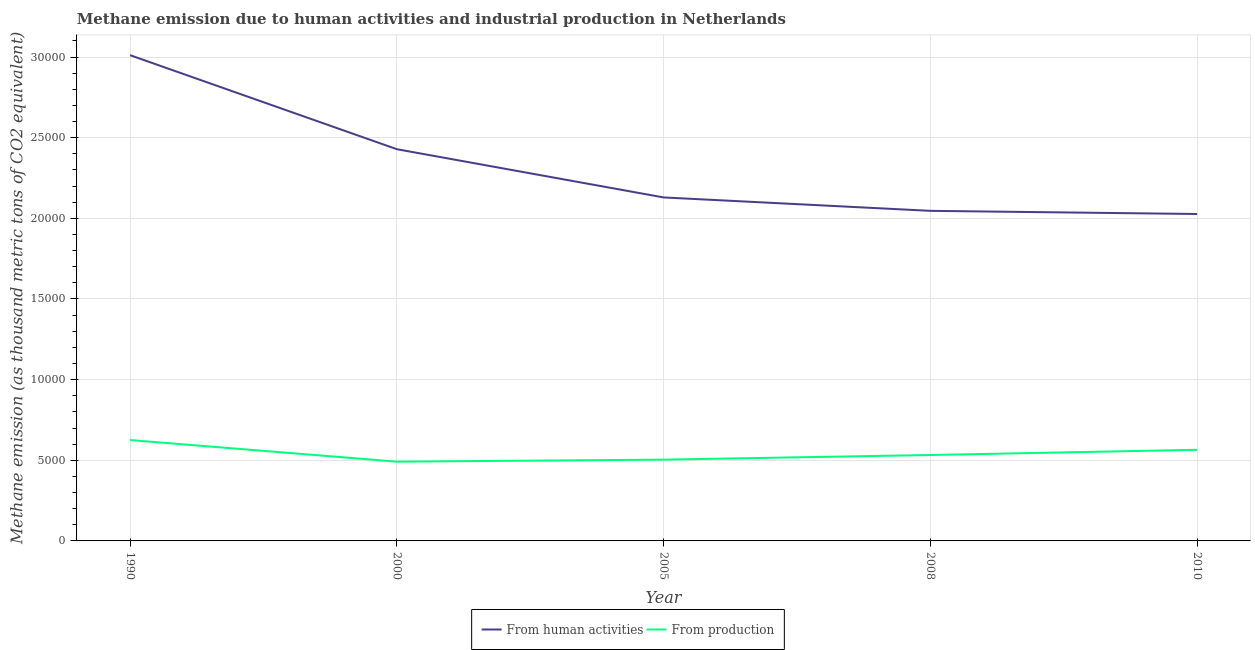How many different coloured lines are there?
Offer a very short reply. 2. Does the line corresponding to amount of emissions generated from industries intersect with the line corresponding to amount of emissions from human activities?
Give a very brief answer. No. What is the amount of emissions generated from industries in 2008?
Keep it short and to the point. 5326.8. Across all years, what is the maximum amount of emissions from human activities?
Make the answer very short. 3.01e+04. Across all years, what is the minimum amount of emissions from human activities?
Give a very brief answer. 2.03e+04. In which year was the amount of emissions from human activities maximum?
Your response must be concise. 1990. In which year was the amount of emissions from human activities minimum?
Offer a terse response. 2010. What is the total amount of emissions generated from industries in the graph?
Your response must be concise. 2.72e+04. What is the difference between the amount of emissions generated from industries in 2008 and that in 2010?
Make the answer very short. -323.2. What is the difference between the amount of emissions from human activities in 2010 and the amount of emissions generated from industries in 1990?
Provide a short and direct response. 1.40e+04. What is the average amount of emissions from human activities per year?
Offer a very short reply. 2.33e+04. In the year 1990, what is the difference between the amount of emissions generated from industries and amount of emissions from human activities?
Provide a short and direct response. -2.39e+04. In how many years, is the amount of emissions generated from industries greater than 7000 thousand metric tons?
Offer a very short reply. 0. What is the ratio of the amount of emissions from human activities in 1990 to that in 2005?
Ensure brevity in your answer.  1.41. Is the amount of emissions from human activities in 2005 less than that in 2008?
Your answer should be compact. No. What is the difference between the highest and the second highest amount of emissions from human activities?
Make the answer very short. 5828.3. What is the difference between the highest and the lowest amount of emissions from human activities?
Your answer should be compact. 9845.8. Is the sum of the amount of emissions generated from industries in 1990 and 2000 greater than the maximum amount of emissions from human activities across all years?
Give a very brief answer. No. Is the amount of emissions generated from industries strictly greater than the amount of emissions from human activities over the years?
Ensure brevity in your answer.  No. Is the amount of emissions generated from industries strictly less than the amount of emissions from human activities over the years?
Your response must be concise. Yes. How many lines are there?
Keep it short and to the point. 2. How many years are there in the graph?
Your response must be concise. 5. Are the values on the major ticks of Y-axis written in scientific E-notation?
Keep it short and to the point. No. Does the graph contain any zero values?
Make the answer very short. No. Does the graph contain grids?
Make the answer very short. Yes. Where does the legend appear in the graph?
Offer a very short reply. Bottom center. How many legend labels are there?
Keep it short and to the point. 2. How are the legend labels stacked?
Your answer should be compact. Horizontal. What is the title of the graph?
Ensure brevity in your answer.  Methane emission due to human activities and industrial production in Netherlands. What is the label or title of the Y-axis?
Your answer should be very brief. Methane emission (as thousand metric tons of CO2 equivalent). What is the Methane emission (as thousand metric tons of CO2 equivalent) of From human activities in 1990?
Your answer should be very brief. 3.01e+04. What is the Methane emission (as thousand metric tons of CO2 equivalent) of From production in 1990?
Offer a very short reply. 6254.4. What is the Methane emission (as thousand metric tons of CO2 equivalent) of From human activities in 2000?
Provide a succinct answer. 2.43e+04. What is the Methane emission (as thousand metric tons of CO2 equivalent) in From production in 2000?
Ensure brevity in your answer.  4913.4. What is the Methane emission (as thousand metric tons of CO2 equivalent) in From human activities in 2005?
Your answer should be compact. 2.13e+04. What is the Methane emission (as thousand metric tons of CO2 equivalent) of From production in 2005?
Offer a terse response. 5039.5. What is the Methane emission (as thousand metric tons of CO2 equivalent) of From human activities in 2008?
Make the answer very short. 2.05e+04. What is the Methane emission (as thousand metric tons of CO2 equivalent) in From production in 2008?
Provide a succinct answer. 5326.8. What is the Methane emission (as thousand metric tons of CO2 equivalent) of From human activities in 2010?
Your answer should be compact. 2.03e+04. What is the Methane emission (as thousand metric tons of CO2 equivalent) of From production in 2010?
Your answer should be very brief. 5650. Across all years, what is the maximum Methane emission (as thousand metric tons of CO2 equivalent) in From human activities?
Provide a short and direct response. 3.01e+04. Across all years, what is the maximum Methane emission (as thousand metric tons of CO2 equivalent) of From production?
Keep it short and to the point. 6254.4. Across all years, what is the minimum Methane emission (as thousand metric tons of CO2 equivalent) of From human activities?
Offer a very short reply. 2.03e+04. Across all years, what is the minimum Methane emission (as thousand metric tons of CO2 equivalent) in From production?
Give a very brief answer. 4913.4. What is the total Methane emission (as thousand metric tons of CO2 equivalent) of From human activities in the graph?
Ensure brevity in your answer.  1.16e+05. What is the total Methane emission (as thousand metric tons of CO2 equivalent) in From production in the graph?
Keep it short and to the point. 2.72e+04. What is the difference between the Methane emission (as thousand metric tons of CO2 equivalent) of From human activities in 1990 and that in 2000?
Provide a succinct answer. 5828.3. What is the difference between the Methane emission (as thousand metric tons of CO2 equivalent) of From production in 1990 and that in 2000?
Give a very brief answer. 1341. What is the difference between the Methane emission (as thousand metric tons of CO2 equivalent) in From human activities in 1990 and that in 2005?
Your answer should be very brief. 8818.6. What is the difference between the Methane emission (as thousand metric tons of CO2 equivalent) of From production in 1990 and that in 2005?
Make the answer very short. 1214.9. What is the difference between the Methane emission (as thousand metric tons of CO2 equivalent) in From human activities in 1990 and that in 2008?
Make the answer very short. 9650.1. What is the difference between the Methane emission (as thousand metric tons of CO2 equivalent) in From production in 1990 and that in 2008?
Offer a very short reply. 927.6. What is the difference between the Methane emission (as thousand metric tons of CO2 equivalent) in From human activities in 1990 and that in 2010?
Provide a succinct answer. 9845.8. What is the difference between the Methane emission (as thousand metric tons of CO2 equivalent) of From production in 1990 and that in 2010?
Give a very brief answer. 604.4. What is the difference between the Methane emission (as thousand metric tons of CO2 equivalent) of From human activities in 2000 and that in 2005?
Give a very brief answer. 2990.3. What is the difference between the Methane emission (as thousand metric tons of CO2 equivalent) in From production in 2000 and that in 2005?
Offer a very short reply. -126.1. What is the difference between the Methane emission (as thousand metric tons of CO2 equivalent) of From human activities in 2000 and that in 2008?
Make the answer very short. 3821.8. What is the difference between the Methane emission (as thousand metric tons of CO2 equivalent) in From production in 2000 and that in 2008?
Your answer should be compact. -413.4. What is the difference between the Methane emission (as thousand metric tons of CO2 equivalent) of From human activities in 2000 and that in 2010?
Make the answer very short. 4017.5. What is the difference between the Methane emission (as thousand metric tons of CO2 equivalent) of From production in 2000 and that in 2010?
Your response must be concise. -736.6. What is the difference between the Methane emission (as thousand metric tons of CO2 equivalent) in From human activities in 2005 and that in 2008?
Keep it short and to the point. 831.5. What is the difference between the Methane emission (as thousand metric tons of CO2 equivalent) in From production in 2005 and that in 2008?
Keep it short and to the point. -287.3. What is the difference between the Methane emission (as thousand metric tons of CO2 equivalent) in From human activities in 2005 and that in 2010?
Your answer should be very brief. 1027.2. What is the difference between the Methane emission (as thousand metric tons of CO2 equivalent) of From production in 2005 and that in 2010?
Offer a terse response. -610.5. What is the difference between the Methane emission (as thousand metric tons of CO2 equivalent) of From human activities in 2008 and that in 2010?
Provide a short and direct response. 195.7. What is the difference between the Methane emission (as thousand metric tons of CO2 equivalent) of From production in 2008 and that in 2010?
Offer a terse response. -323.2. What is the difference between the Methane emission (as thousand metric tons of CO2 equivalent) in From human activities in 1990 and the Methane emission (as thousand metric tons of CO2 equivalent) in From production in 2000?
Your answer should be compact. 2.52e+04. What is the difference between the Methane emission (as thousand metric tons of CO2 equivalent) in From human activities in 1990 and the Methane emission (as thousand metric tons of CO2 equivalent) in From production in 2005?
Your response must be concise. 2.51e+04. What is the difference between the Methane emission (as thousand metric tons of CO2 equivalent) in From human activities in 1990 and the Methane emission (as thousand metric tons of CO2 equivalent) in From production in 2008?
Provide a succinct answer. 2.48e+04. What is the difference between the Methane emission (as thousand metric tons of CO2 equivalent) of From human activities in 1990 and the Methane emission (as thousand metric tons of CO2 equivalent) of From production in 2010?
Ensure brevity in your answer.  2.45e+04. What is the difference between the Methane emission (as thousand metric tons of CO2 equivalent) of From human activities in 2000 and the Methane emission (as thousand metric tons of CO2 equivalent) of From production in 2005?
Give a very brief answer. 1.92e+04. What is the difference between the Methane emission (as thousand metric tons of CO2 equivalent) of From human activities in 2000 and the Methane emission (as thousand metric tons of CO2 equivalent) of From production in 2008?
Ensure brevity in your answer.  1.90e+04. What is the difference between the Methane emission (as thousand metric tons of CO2 equivalent) of From human activities in 2000 and the Methane emission (as thousand metric tons of CO2 equivalent) of From production in 2010?
Make the answer very short. 1.86e+04. What is the difference between the Methane emission (as thousand metric tons of CO2 equivalent) of From human activities in 2005 and the Methane emission (as thousand metric tons of CO2 equivalent) of From production in 2008?
Your answer should be very brief. 1.60e+04. What is the difference between the Methane emission (as thousand metric tons of CO2 equivalent) of From human activities in 2005 and the Methane emission (as thousand metric tons of CO2 equivalent) of From production in 2010?
Offer a terse response. 1.56e+04. What is the difference between the Methane emission (as thousand metric tons of CO2 equivalent) of From human activities in 2008 and the Methane emission (as thousand metric tons of CO2 equivalent) of From production in 2010?
Provide a succinct answer. 1.48e+04. What is the average Methane emission (as thousand metric tons of CO2 equivalent) in From human activities per year?
Offer a very short reply. 2.33e+04. What is the average Methane emission (as thousand metric tons of CO2 equivalent) in From production per year?
Your answer should be very brief. 5436.82. In the year 1990, what is the difference between the Methane emission (as thousand metric tons of CO2 equivalent) of From human activities and Methane emission (as thousand metric tons of CO2 equivalent) of From production?
Ensure brevity in your answer.  2.39e+04. In the year 2000, what is the difference between the Methane emission (as thousand metric tons of CO2 equivalent) of From human activities and Methane emission (as thousand metric tons of CO2 equivalent) of From production?
Make the answer very short. 1.94e+04. In the year 2005, what is the difference between the Methane emission (as thousand metric tons of CO2 equivalent) in From human activities and Methane emission (as thousand metric tons of CO2 equivalent) in From production?
Your response must be concise. 1.63e+04. In the year 2008, what is the difference between the Methane emission (as thousand metric tons of CO2 equivalent) of From human activities and Methane emission (as thousand metric tons of CO2 equivalent) of From production?
Give a very brief answer. 1.51e+04. In the year 2010, what is the difference between the Methane emission (as thousand metric tons of CO2 equivalent) in From human activities and Methane emission (as thousand metric tons of CO2 equivalent) in From production?
Give a very brief answer. 1.46e+04. What is the ratio of the Methane emission (as thousand metric tons of CO2 equivalent) of From human activities in 1990 to that in 2000?
Ensure brevity in your answer.  1.24. What is the ratio of the Methane emission (as thousand metric tons of CO2 equivalent) in From production in 1990 to that in 2000?
Provide a short and direct response. 1.27. What is the ratio of the Methane emission (as thousand metric tons of CO2 equivalent) in From human activities in 1990 to that in 2005?
Offer a very short reply. 1.41. What is the ratio of the Methane emission (as thousand metric tons of CO2 equivalent) of From production in 1990 to that in 2005?
Your response must be concise. 1.24. What is the ratio of the Methane emission (as thousand metric tons of CO2 equivalent) of From human activities in 1990 to that in 2008?
Provide a succinct answer. 1.47. What is the ratio of the Methane emission (as thousand metric tons of CO2 equivalent) in From production in 1990 to that in 2008?
Your answer should be very brief. 1.17. What is the ratio of the Methane emission (as thousand metric tons of CO2 equivalent) of From human activities in 1990 to that in 2010?
Your response must be concise. 1.49. What is the ratio of the Methane emission (as thousand metric tons of CO2 equivalent) in From production in 1990 to that in 2010?
Ensure brevity in your answer.  1.11. What is the ratio of the Methane emission (as thousand metric tons of CO2 equivalent) of From human activities in 2000 to that in 2005?
Provide a short and direct response. 1.14. What is the ratio of the Methane emission (as thousand metric tons of CO2 equivalent) in From production in 2000 to that in 2005?
Your answer should be compact. 0.97. What is the ratio of the Methane emission (as thousand metric tons of CO2 equivalent) in From human activities in 2000 to that in 2008?
Your response must be concise. 1.19. What is the ratio of the Methane emission (as thousand metric tons of CO2 equivalent) of From production in 2000 to that in 2008?
Your answer should be compact. 0.92. What is the ratio of the Methane emission (as thousand metric tons of CO2 equivalent) of From human activities in 2000 to that in 2010?
Offer a very short reply. 1.2. What is the ratio of the Methane emission (as thousand metric tons of CO2 equivalent) of From production in 2000 to that in 2010?
Your answer should be very brief. 0.87. What is the ratio of the Methane emission (as thousand metric tons of CO2 equivalent) in From human activities in 2005 to that in 2008?
Make the answer very short. 1.04. What is the ratio of the Methane emission (as thousand metric tons of CO2 equivalent) of From production in 2005 to that in 2008?
Make the answer very short. 0.95. What is the ratio of the Methane emission (as thousand metric tons of CO2 equivalent) in From human activities in 2005 to that in 2010?
Provide a short and direct response. 1.05. What is the ratio of the Methane emission (as thousand metric tons of CO2 equivalent) in From production in 2005 to that in 2010?
Offer a terse response. 0.89. What is the ratio of the Methane emission (as thousand metric tons of CO2 equivalent) of From human activities in 2008 to that in 2010?
Ensure brevity in your answer.  1.01. What is the ratio of the Methane emission (as thousand metric tons of CO2 equivalent) of From production in 2008 to that in 2010?
Give a very brief answer. 0.94. What is the difference between the highest and the second highest Methane emission (as thousand metric tons of CO2 equivalent) of From human activities?
Give a very brief answer. 5828.3. What is the difference between the highest and the second highest Methane emission (as thousand metric tons of CO2 equivalent) of From production?
Make the answer very short. 604.4. What is the difference between the highest and the lowest Methane emission (as thousand metric tons of CO2 equivalent) of From human activities?
Offer a terse response. 9845.8. What is the difference between the highest and the lowest Methane emission (as thousand metric tons of CO2 equivalent) in From production?
Make the answer very short. 1341. 